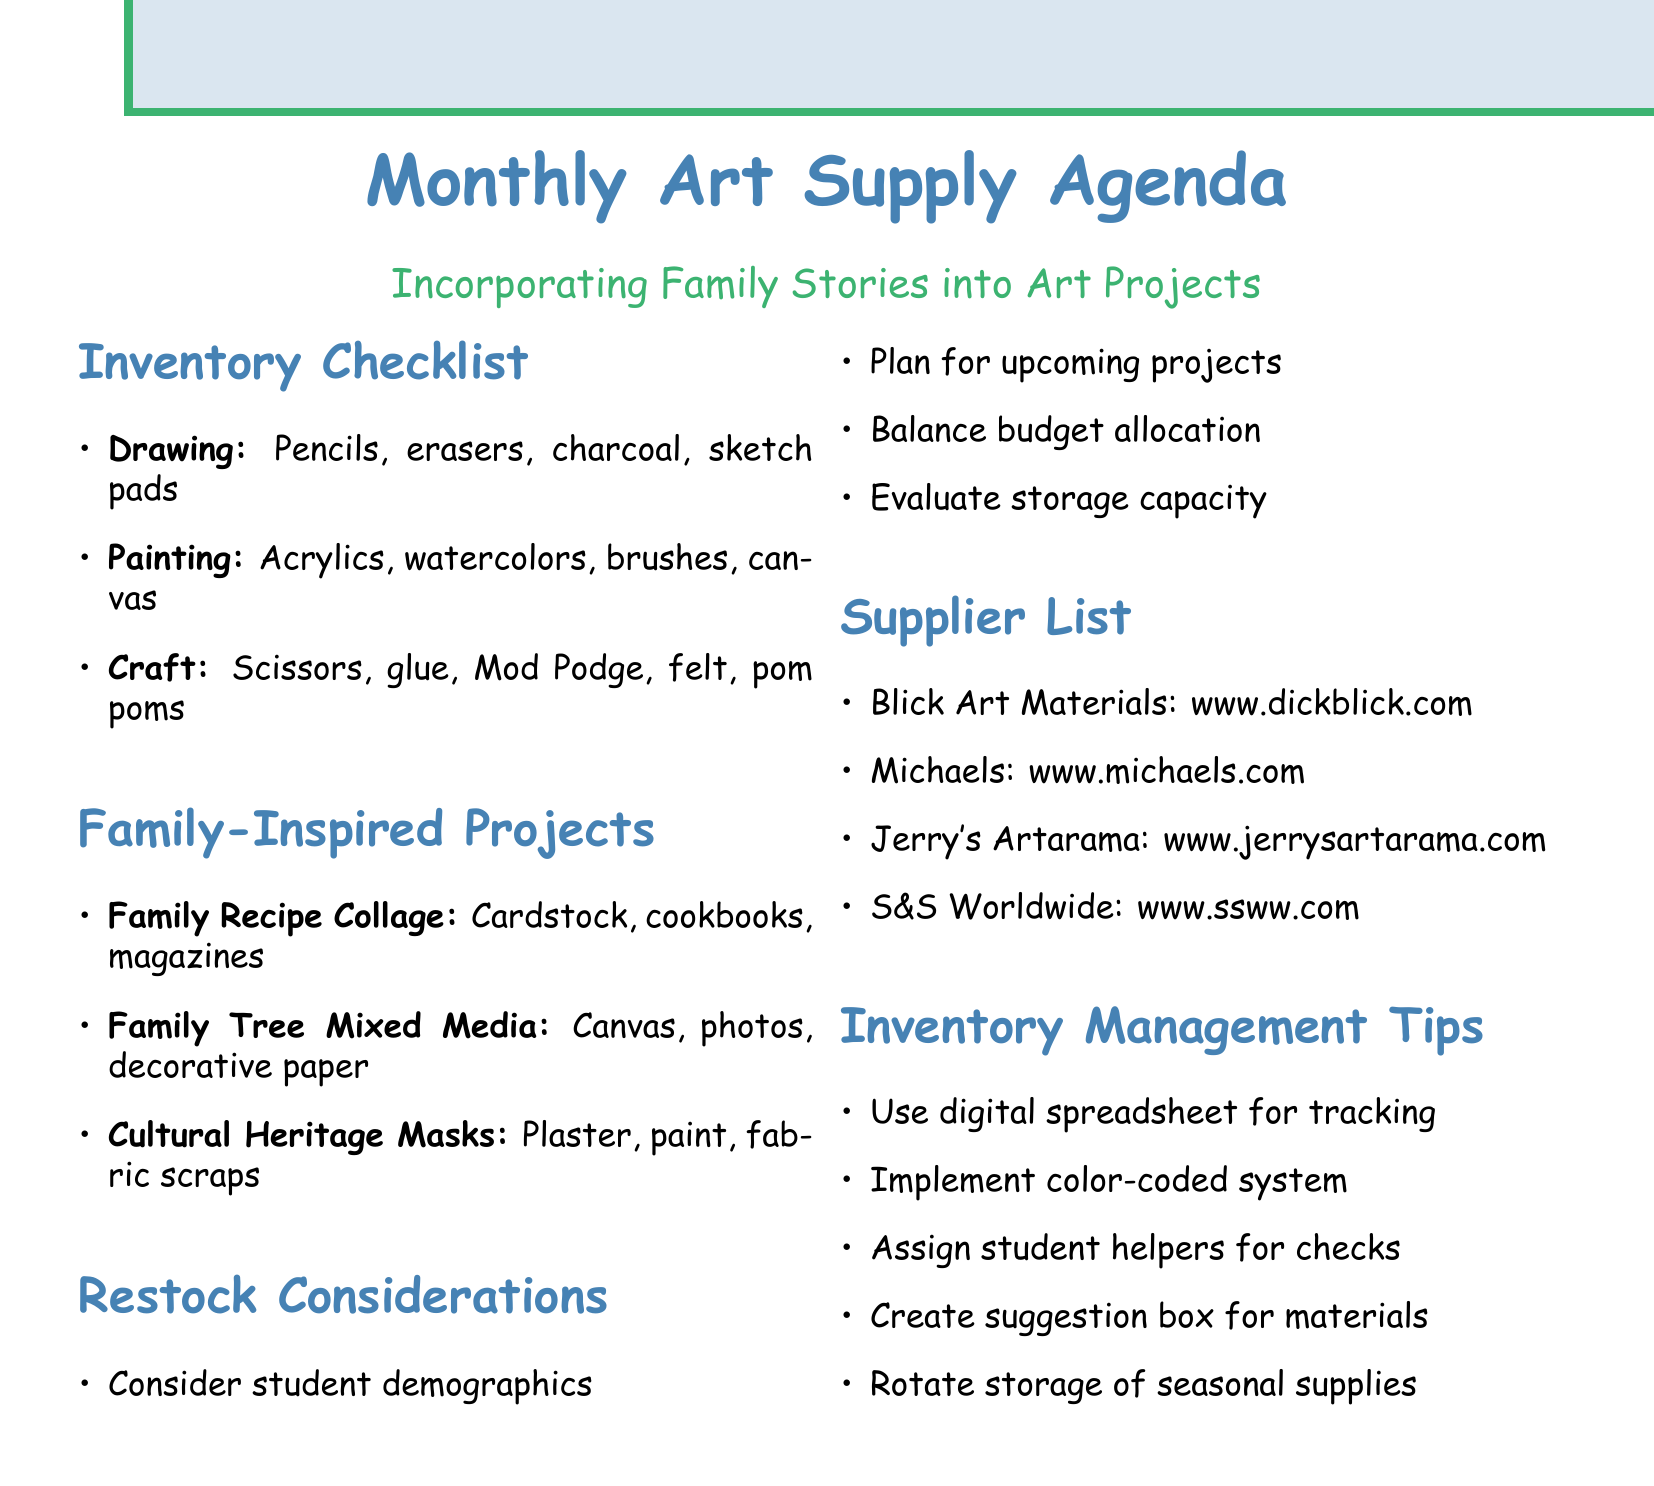What is the primary category of supplies listed first? The first category in the supplies list is "Drawing Supplies."
Answer: Drawing Supplies Which company specializes in craft supplies? The company noted for specializing in craft supplies is Michaels.
Answer: Michaels How many family-inspired projects are listed? There are three family-inspired projects detailed in the document.
Answer: Three What material is required for the "Cultural Heritage Masks" project? The materials mentioned for the Cultural Heritage Masks project include Plaster strips.
Answer: Plaster strips What is one factor to consider for restocking supplies? One of the factors is to consider student demographics when restocking.
Answer: Student Demographics What website can be visited for Blick Art Materials? The website listed for Blick Art Materials is www.dickblick.com.
Answer: www.dickblick.com What type of paper is required for the "Family Recipe Collage" project? The project requires cardstock paper.
Answer: Cardstock paper Name a tip for managing inventory. One suggested tip for managing inventory is to use a digital spreadsheet to track supply levels.
Answer: Use a digital spreadsheet What is the weight of the watercolor paper recommended? The recommended weight for watercolor paper is 140 lb.
Answer: 140 lb 